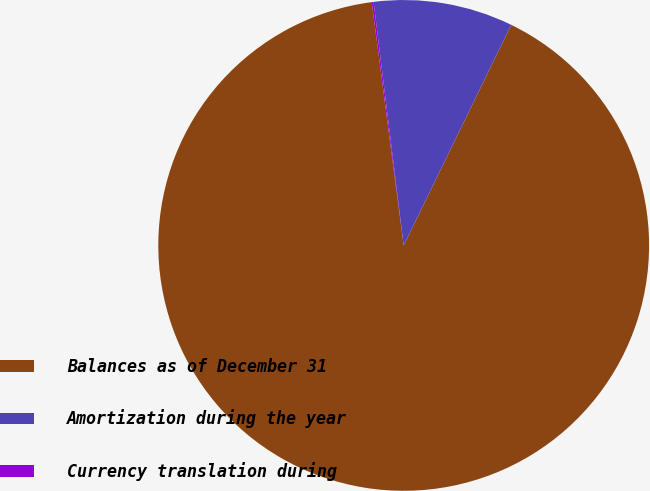Convert chart to OTSL. <chart><loc_0><loc_0><loc_500><loc_500><pie_chart><fcel>Balances as of December 31<fcel>Amortization during the year<fcel>Currency translation during<nl><fcel>90.7%<fcel>9.18%<fcel>0.12%<nl></chart> 